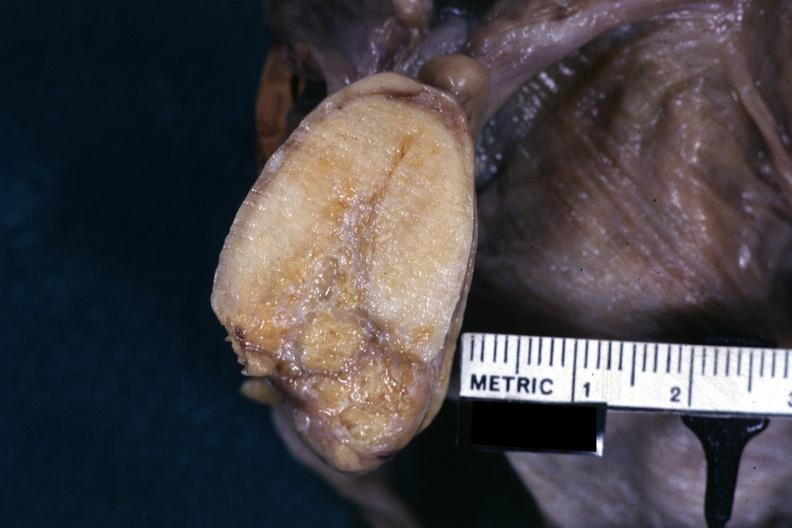s lesion present?
Answer the question using a single word or phrase. No 